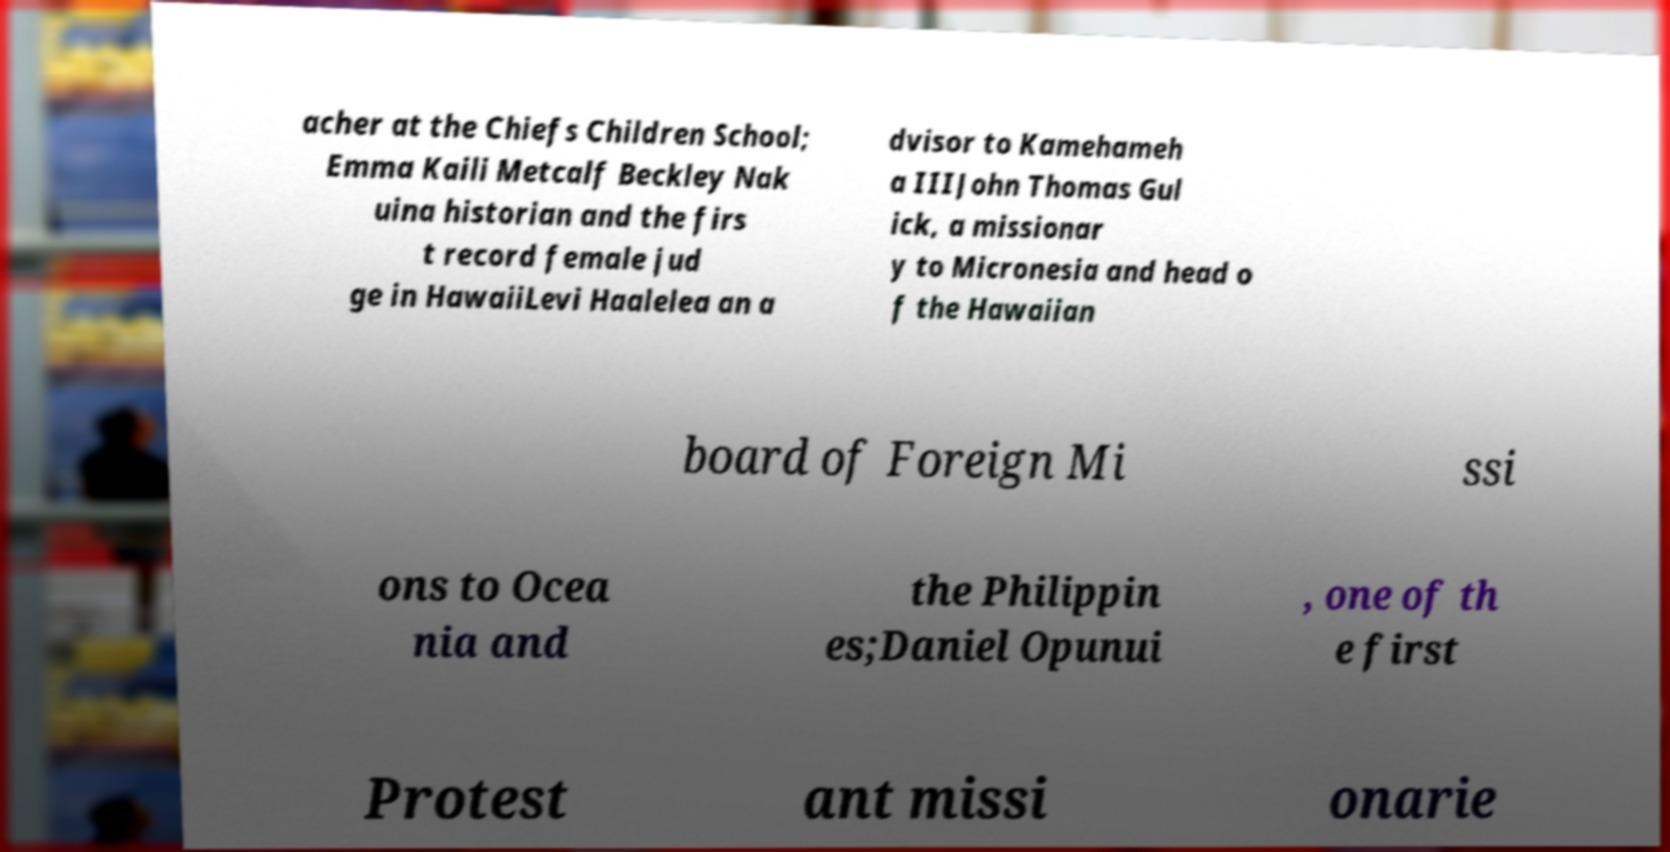I need the written content from this picture converted into text. Can you do that? acher at the Chiefs Children School; Emma Kaili Metcalf Beckley Nak uina historian and the firs t record female jud ge in HawaiiLevi Haalelea an a dvisor to Kamehameh a IIIJohn Thomas Gul ick, a missionar y to Micronesia and head o f the Hawaiian board of Foreign Mi ssi ons to Ocea nia and the Philippin es;Daniel Opunui , one of th e first Protest ant missi onarie 